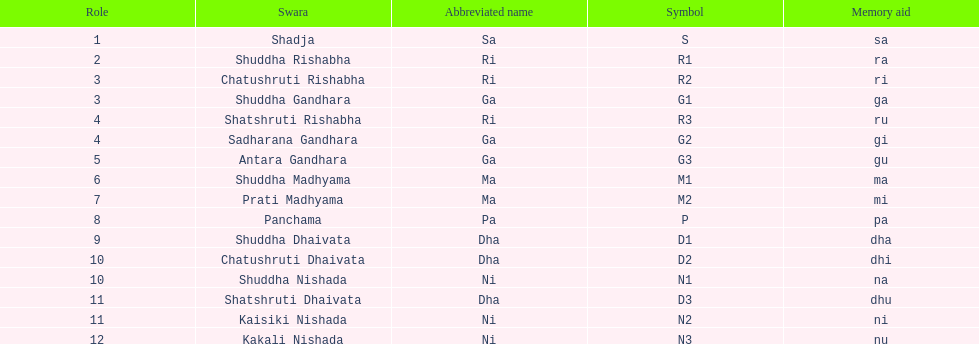Find the 9th position swara. what is its short name? Dha. 